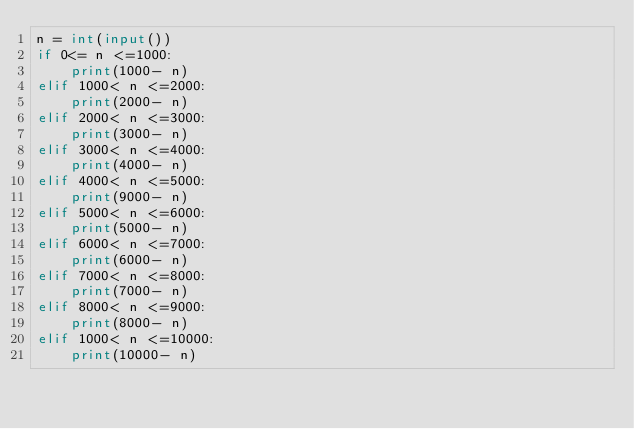Convert code to text. <code><loc_0><loc_0><loc_500><loc_500><_Python_>n = int(input())
if 0<= n <=1000:
    print(1000- n)
elif 1000< n <=2000:
    print(2000- n)
elif 2000< n <=3000:
    print(3000- n)
elif 3000< n <=4000:
    print(4000- n)
elif 4000< n <=5000:
    print(9000- n)
elif 5000< n <=6000:
    print(5000- n)
elif 6000< n <=7000:
    print(6000- n)
elif 7000< n <=8000:
    print(7000- n)
elif 8000< n <=9000:
    print(8000- n)
elif 1000< n <=10000:
    print(10000- n)</code> 